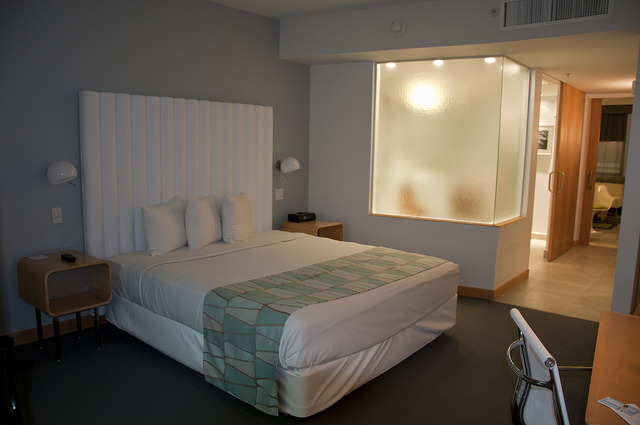What features in this image indicate whether the room is meant for work or relaxation? The room includes a bed and a relaxing ambiance, suggesting it's meant more for relaxation. However, the presence of a chair and a work desk indicates that it could also serve as a workspace, albeit with limited surface area. 